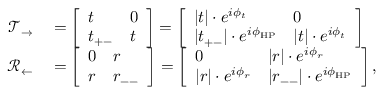Convert formula to latex. <formula><loc_0><loc_0><loc_500><loc_500>\begin{array} { r l } { \mathcal { T } _ { \rightarrow } } & = \left [ \begin{array} { l l } { t } & { 0 } \\ { t _ { + - } } & { t } \end{array} \right ] = \left [ \begin{array} { l l } { | t | \cdot e ^ { i \phi _ { t } } } & { 0 } \\ { | t _ { + - } | \cdot e ^ { i \phi _ { H P } } } & { | t | \cdot e ^ { i \phi _ { t } } } \end{array} \right ] } \\ { \mathcal { R } _ { \leftarrow } } & = \left [ \begin{array} { l l } { 0 } & { r } \\ { r } & { r _ { - - } } \end{array} \right ] = \left [ \begin{array} { l l } { 0 } & { | r | \cdot e ^ { i \phi _ { r } } } \\ { | r | \cdot e ^ { i \phi _ { r } } } & { | r _ { - - } | \cdot e ^ { i \phi _ { H P } } } \end{array} \right ] , } \end{array}</formula> 